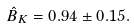<formula> <loc_0><loc_0><loc_500><loc_500>\hat { B } _ { K } = 0 . 9 4 \pm 0 . 1 5 .</formula> 